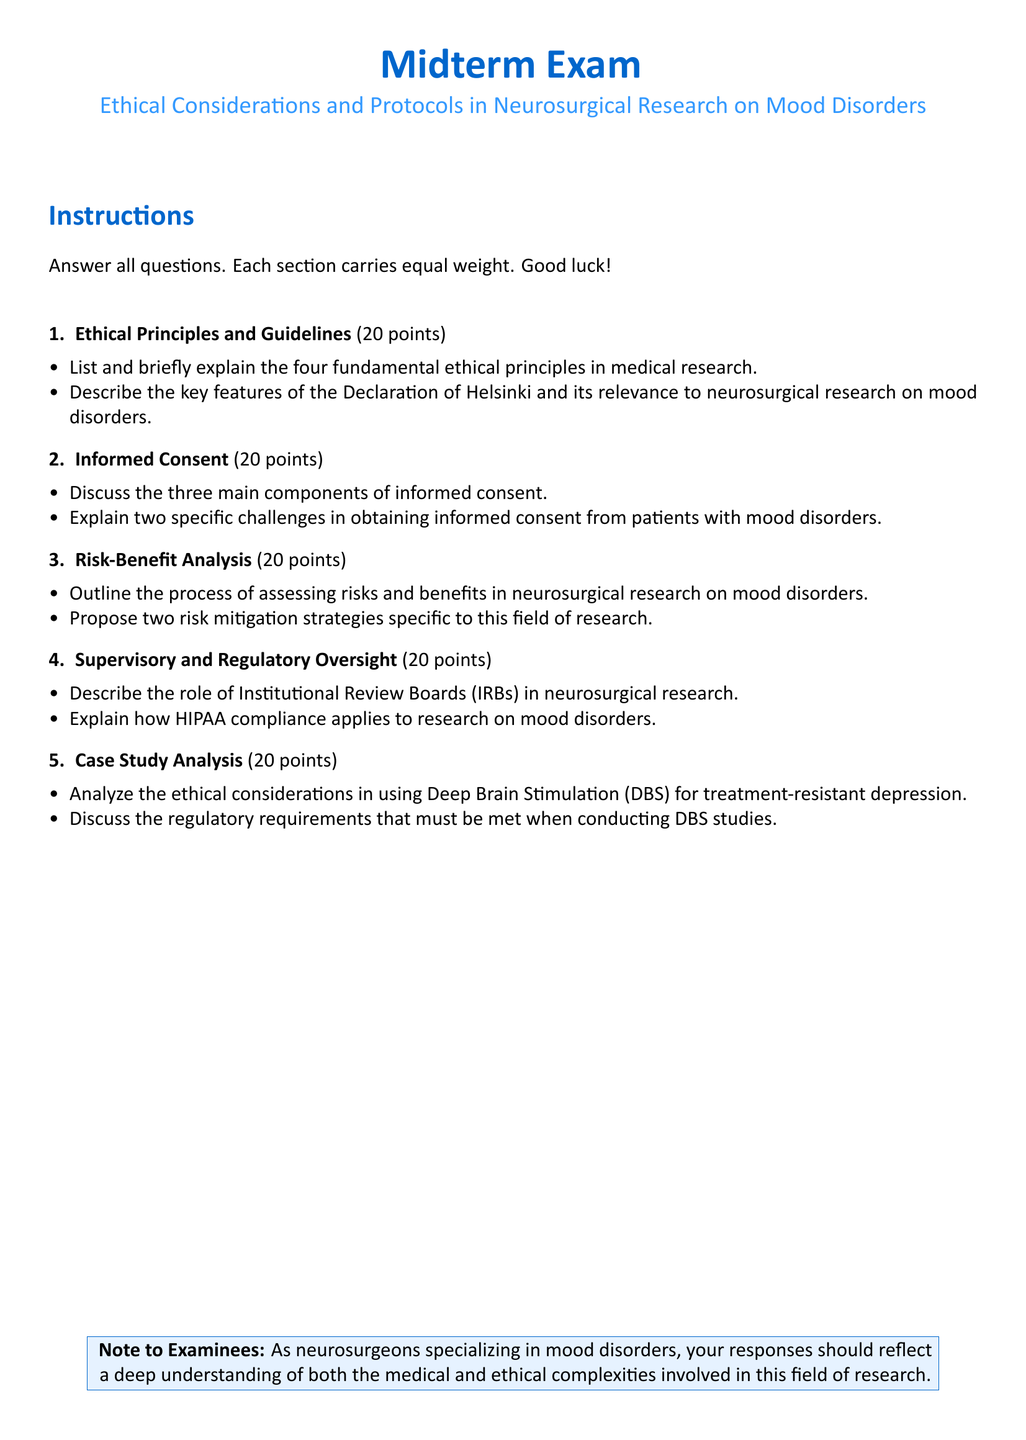What is the title of the exam? The title of the exam is found at the beginning of the document, indicating the subject matter it covers.
Answer: Midterm Exam What are the two main components in the title of the second section? The title of the second section summarizes the focus of questions regarding patient autonomy and rights in research.
Answer: Informed Consent How many points is the section on Risk-Benefit Analysis worth? Each section is explicitly stated to have equal weight, with the total number of points allocated for the exam specified.
Answer: 20 points What specific research method is discussed in the case study section? The case study section analyzes one specific treatment method for patients with treatment-resistant mood disorders.
Answer: Deep Brain Stimulation (DBS) Which regulatory body is mentioned in relation to supervisory oversight? The role of this body is described regarding ethical review processes for research approval, ensuring participant safety and rights.
Answer: Institutional Review Boards (IRBs) Name one ethical principle noted in the document. This section outlines core ethical standards that govern medical research practices and patient treatment.
Answer: Autonomy What is highlighted in the exam instructions regarding the responses? The instructions provide guidance on the expectations for exam responses, emphasizing a specific understanding on the subject.
Answer: Deep understanding of both the medical and ethical complexities What color is used for the headings in the document? The color choice for headings can affect the overall visual clarity and engagement of the document.
Answer: RGB(0,102,204) 